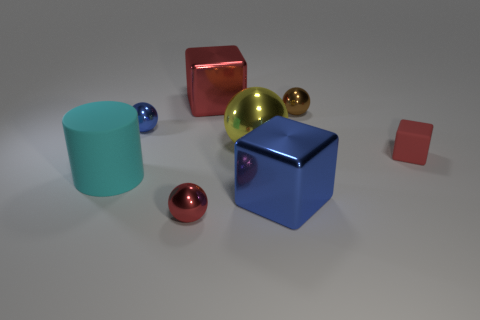How many big metallic objects have the same color as the large sphere? In the image, there is one large golden sphere and one smaller sphere of the same color. However, it should be noted that the term 'big' is subjective. If we are considering objects roughly similar in size to the large sphere, then the answer is one. But if the smaller sphere is included despite being clearly smaller in size, then the count would be two. 